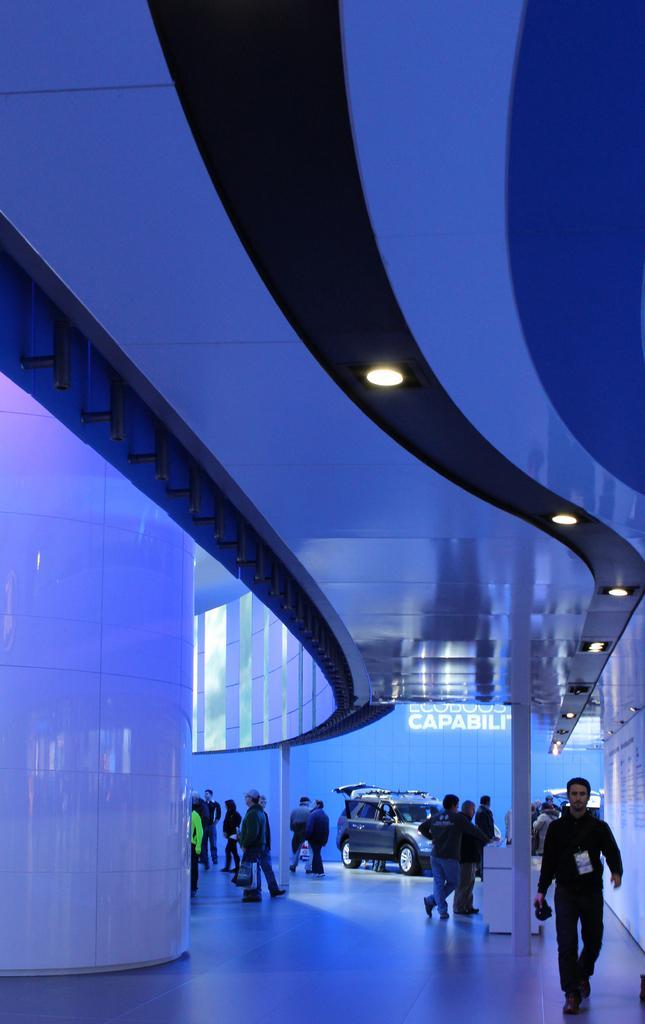Describe this image in one or two sentences. In this image, we can see a group of people who are walking in the building. In the background, we can see a car on the ground. 